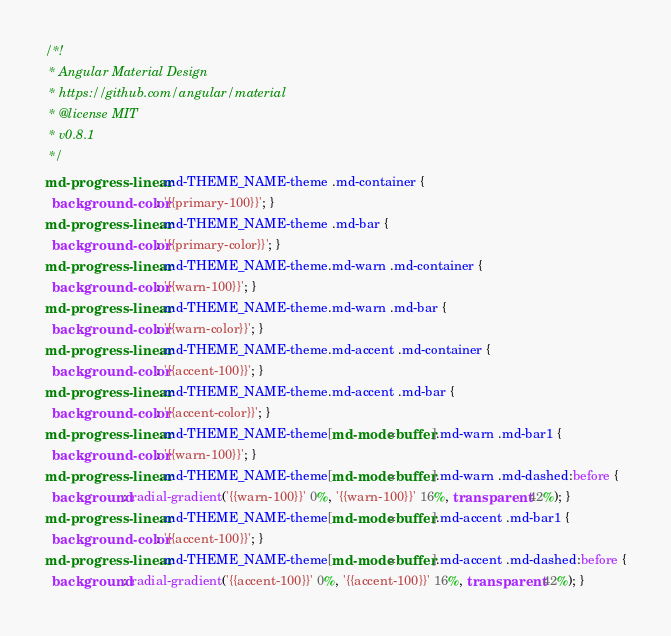<code> <loc_0><loc_0><loc_500><loc_500><_CSS_>/*!
 * Angular Material Design
 * https://github.com/angular/material
 * @license MIT
 * v0.8.1
 */
md-progress-linear.md-THEME_NAME-theme .md-container {
  background-color: '{{primary-100}}'; }
md-progress-linear.md-THEME_NAME-theme .md-bar {
  background-color: '{{primary-color}}'; }
md-progress-linear.md-THEME_NAME-theme.md-warn .md-container {
  background-color: '{{warn-100}}'; }
md-progress-linear.md-THEME_NAME-theme.md-warn .md-bar {
  background-color: '{{warn-color}}'; }
md-progress-linear.md-THEME_NAME-theme.md-accent .md-container {
  background-color: '{{accent-100}}'; }
md-progress-linear.md-THEME_NAME-theme.md-accent .md-bar {
  background-color: '{{accent-color}}'; }
md-progress-linear.md-THEME_NAME-theme[md-mode=buffer].md-warn .md-bar1 {
  background-color: '{{warn-100}}'; }
md-progress-linear.md-THEME_NAME-theme[md-mode=buffer].md-warn .md-dashed:before {
  background: radial-gradient('{{warn-100}}' 0%, '{{warn-100}}' 16%, transparent 42%); }
md-progress-linear.md-THEME_NAME-theme[md-mode=buffer].md-accent .md-bar1 {
  background-color: '{{accent-100}}'; }
md-progress-linear.md-THEME_NAME-theme[md-mode=buffer].md-accent .md-dashed:before {
  background: radial-gradient('{{accent-100}}' 0%, '{{accent-100}}' 16%, transparent 42%); }
</code> 